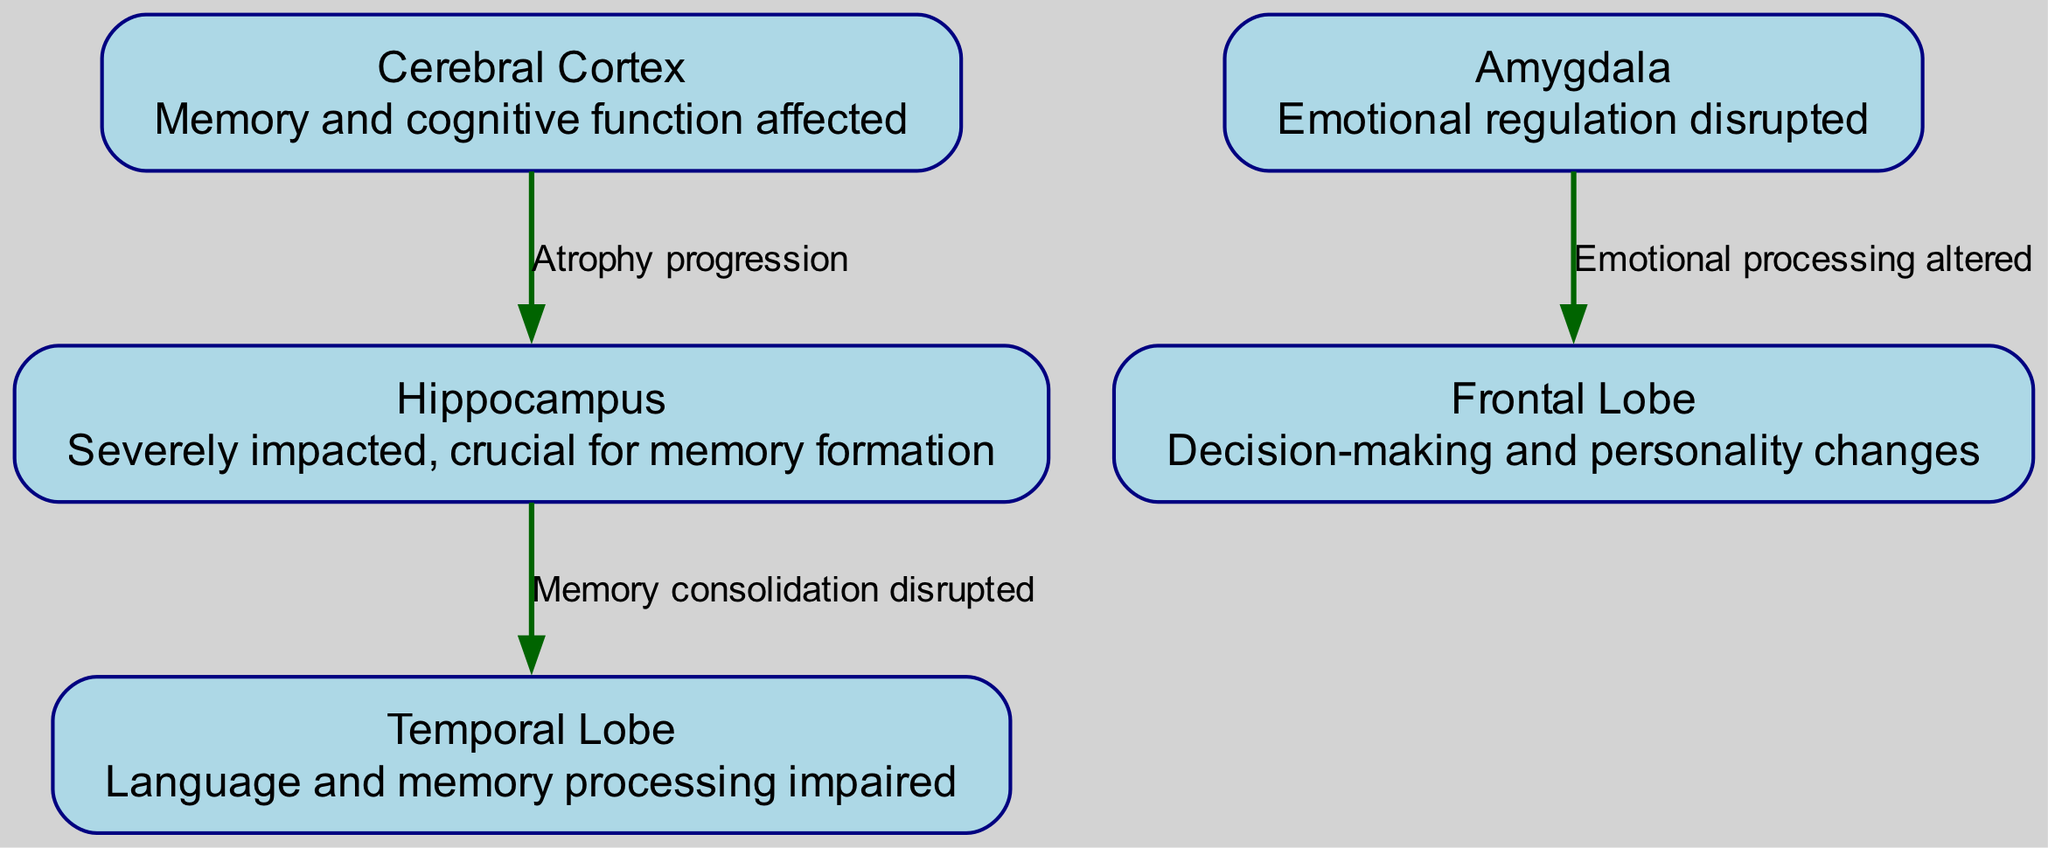What are the labeled regions in the diagram? The diagram includes labels for five regions: Cerebral Cortex, Hippocampus, Amygdala, Temporal Lobe, and Frontal Lobe.
Answer: Cerebral Cortex, Hippocampus, Amygdala, Temporal Lobe, Frontal Lobe Which region is severely impacted in relation to memory formation? The Hippocampus is specifically described as being severely impacted and crucial for memory formation according to the diagram's information.
Answer: Hippocampus How many nodes are represented in the diagram? The diagram contains five nodes, which are the labeled regions representing brain structures affected by Alzheimer's disease.
Answer: Five What label is used to describe the relationship between the Cerebral Cortex and Hippocampus? The relationship is labeled as "Atrophy progression," indicating a connection concerning the degeneration of these areas.
Answer: Atrophy progression What cognitive function does the Frontal Lobe primarily affect? The Frontal Lobe is associated with decision-making and personality changes, according to the diagram's description.
Answer: Decision-making and personality changes Which region is linked to emotional regulation disruption? The Amygdala is the region connected to emotional regulation disruption as stated in the diagram.
Answer: Amygdala What does the edge between the Hippocampus and Temporal Lobe indicate? The edge indicates that memory consolidation is disrupted, suggesting a negative impact on how memories are formed and maintained.
Answer: Memory consolidation disrupted How is emotional processing affected according to the diagram? Emotional processing is altered, which reflects the connections shown between the Amygdala and Frontal Lobe in the diagram.
Answer: Altered What type of diagram is this and what does it represent? This is a Biomedical Diagram, specifically illustrating the structure of the human brain affected by Alzheimer's disease and labeling various impacted regions.
Answer: Biomedical Diagram depicting human brain structure affected by Alzheimer's disease 